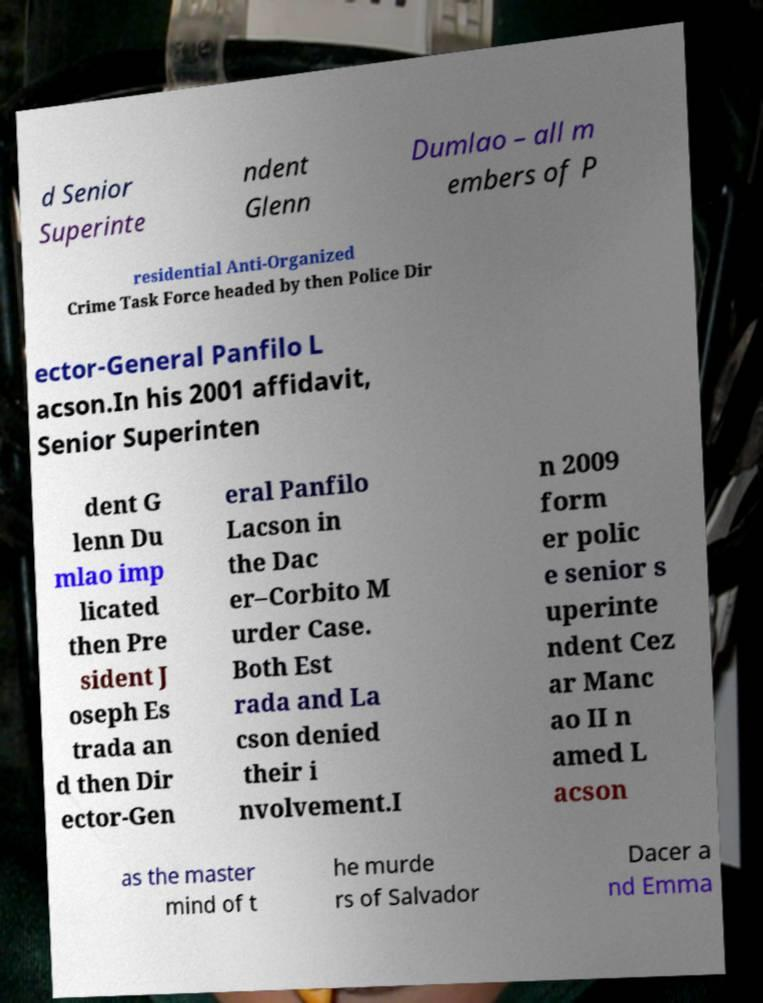Could you assist in decoding the text presented in this image and type it out clearly? d Senior Superinte ndent Glenn Dumlao – all m embers of P residential Anti-Organized Crime Task Force headed by then Police Dir ector-General Panfilo L acson.In his 2001 affidavit, Senior Superinten dent G lenn Du mlao imp licated then Pre sident J oseph Es trada an d then Dir ector-Gen eral Panfilo Lacson in the Dac er–Corbito M urder Case. Both Est rada and La cson denied their i nvolvement.I n 2009 form er polic e senior s uperinte ndent Cez ar Manc ao II n amed L acson as the master mind of t he murde rs of Salvador Dacer a nd Emma 